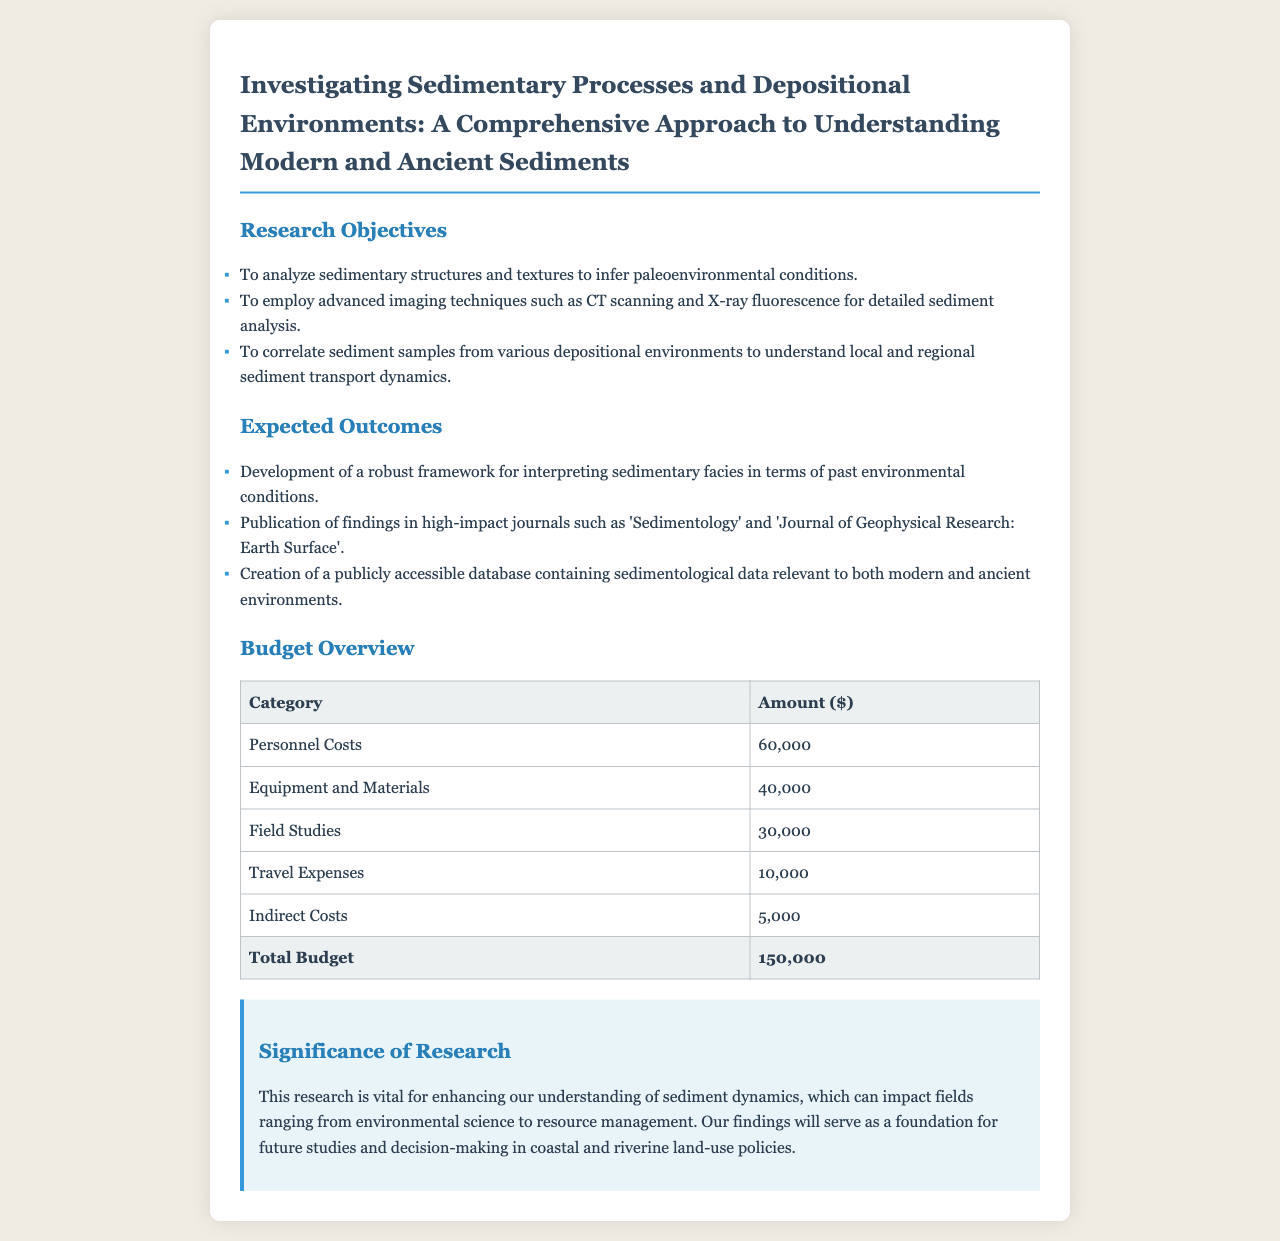what is the total budget? The total budget is listed at the bottom of the budget overview table, totaling $150,000.
Answer: $150,000 what is the first research objective? The first research objective is stated in the document's objectives section, focusing on analyzing sedimentary structures and textures.
Answer: To analyze sedimentary structures and textures to infer paleoenvironmental conditions which journals are highlighted for publication of findings? The document mentions specific journals in the expected outcomes section where findings will be published.
Answer: 'Sedimentology' and 'Journal of Geophysical Research: Earth Surface' how much is allocated for field studies? The budget overview lists the amount allocated specifically for field studies.
Answer: $30,000 what imaging techniques are employed in this research? The document outlines the advanced imaging techniques used for sediment analysis under research objectives.
Answer: CT scanning and X-ray fluorescence what is the significance of this research? The significance section elaborates on the importance of the research for various fields including environmental science.
Answer: Enhancing our understanding of sediment dynamics what category has the highest funding? The budget overview presents various categories and reveals which has the highest allocation.
Answer: Personnel Costs how many research objectives are listed in the document? The objectives section contains a list of specific goals for the research proposal, and counting them provides the answer.
Answer: Three 